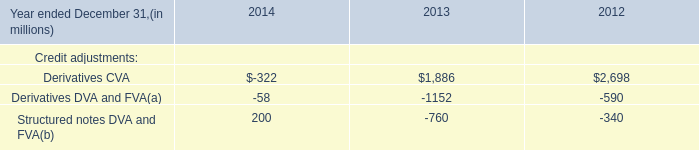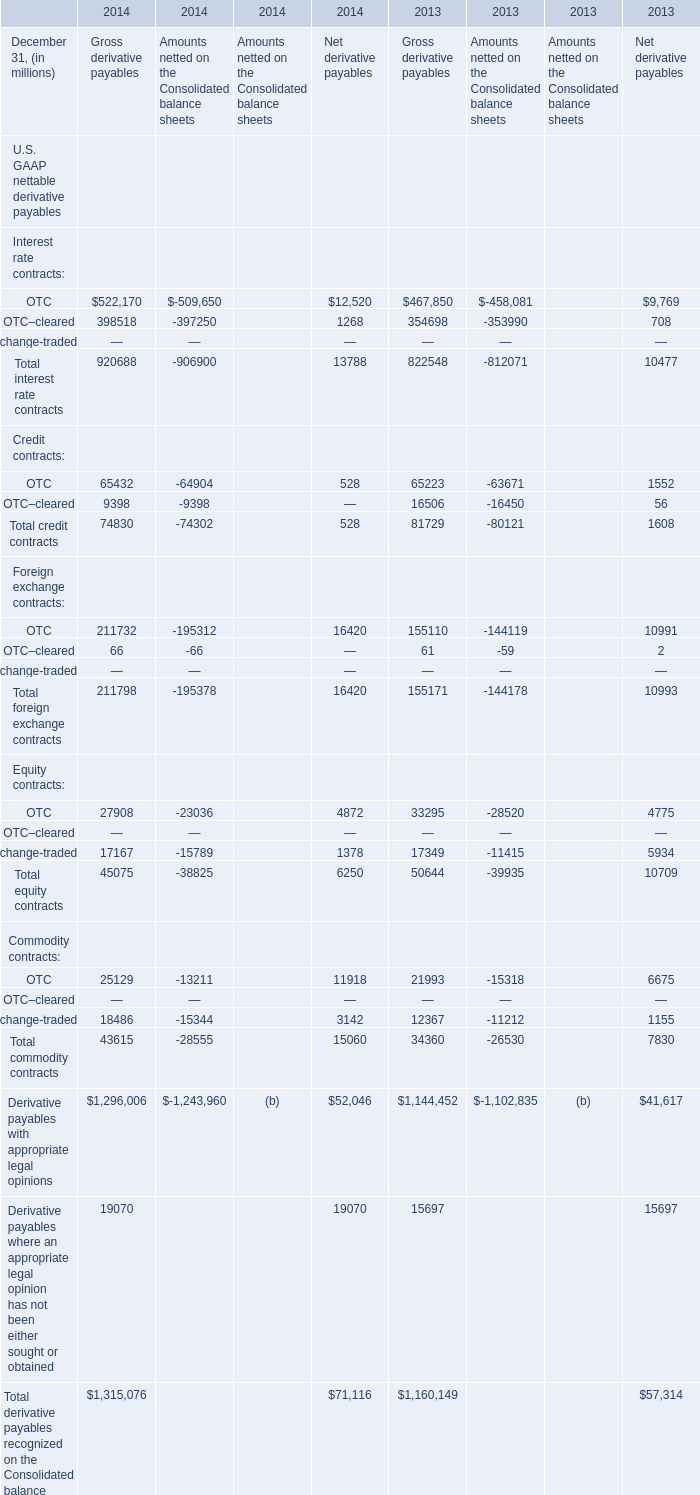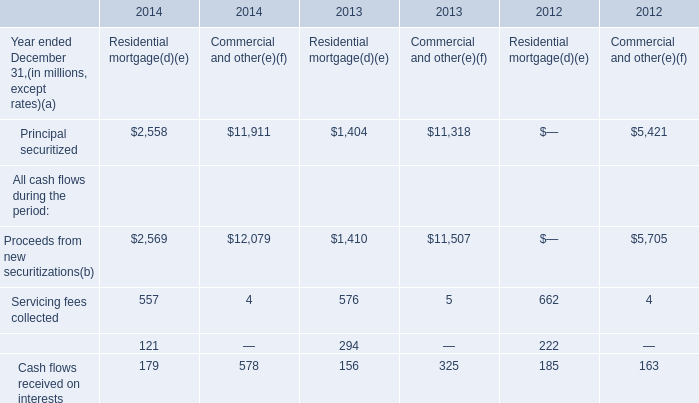Which year is OTC in Gross derivative payables the least? 
Answer: 2013. 